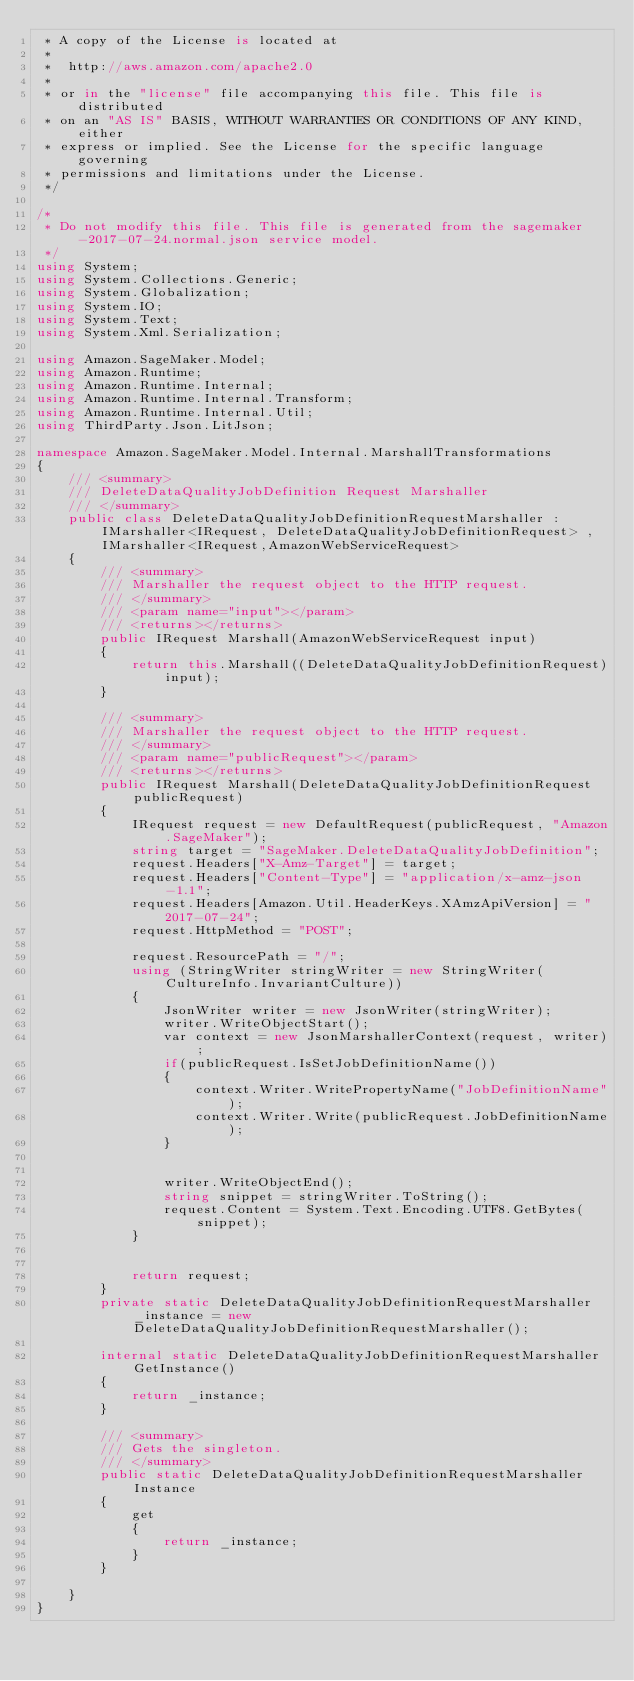Convert code to text. <code><loc_0><loc_0><loc_500><loc_500><_C#_> * A copy of the License is located at
 * 
 *  http://aws.amazon.com/apache2.0
 * 
 * or in the "license" file accompanying this file. This file is distributed
 * on an "AS IS" BASIS, WITHOUT WARRANTIES OR CONDITIONS OF ANY KIND, either
 * express or implied. See the License for the specific language governing
 * permissions and limitations under the License.
 */

/*
 * Do not modify this file. This file is generated from the sagemaker-2017-07-24.normal.json service model.
 */
using System;
using System.Collections.Generic;
using System.Globalization;
using System.IO;
using System.Text;
using System.Xml.Serialization;

using Amazon.SageMaker.Model;
using Amazon.Runtime;
using Amazon.Runtime.Internal;
using Amazon.Runtime.Internal.Transform;
using Amazon.Runtime.Internal.Util;
using ThirdParty.Json.LitJson;

namespace Amazon.SageMaker.Model.Internal.MarshallTransformations
{
    /// <summary>
    /// DeleteDataQualityJobDefinition Request Marshaller
    /// </summary>       
    public class DeleteDataQualityJobDefinitionRequestMarshaller : IMarshaller<IRequest, DeleteDataQualityJobDefinitionRequest> , IMarshaller<IRequest,AmazonWebServiceRequest>
    {
        /// <summary>
        /// Marshaller the request object to the HTTP request.
        /// </summary>  
        /// <param name="input"></param>
        /// <returns></returns>
        public IRequest Marshall(AmazonWebServiceRequest input)
        {
            return this.Marshall((DeleteDataQualityJobDefinitionRequest)input);
        }

        /// <summary>
        /// Marshaller the request object to the HTTP request.
        /// </summary>  
        /// <param name="publicRequest"></param>
        /// <returns></returns>
        public IRequest Marshall(DeleteDataQualityJobDefinitionRequest publicRequest)
        {
            IRequest request = new DefaultRequest(publicRequest, "Amazon.SageMaker");
            string target = "SageMaker.DeleteDataQualityJobDefinition";
            request.Headers["X-Amz-Target"] = target;
            request.Headers["Content-Type"] = "application/x-amz-json-1.1";
            request.Headers[Amazon.Util.HeaderKeys.XAmzApiVersion] = "2017-07-24";            
            request.HttpMethod = "POST";

            request.ResourcePath = "/";
            using (StringWriter stringWriter = new StringWriter(CultureInfo.InvariantCulture))
            {
                JsonWriter writer = new JsonWriter(stringWriter);
                writer.WriteObjectStart();
                var context = new JsonMarshallerContext(request, writer);
                if(publicRequest.IsSetJobDefinitionName())
                {
                    context.Writer.WritePropertyName("JobDefinitionName");
                    context.Writer.Write(publicRequest.JobDefinitionName);
                }

        
                writer.WriteObjectEnd();
                string snippet = stringWriter.ToString();
                request.Content = System.Text.Encoding.UTF8.GetBytes(snippet);
            }


            return request;
        }
        private static DeleteDataQualityJobDefinitionRequestMarshaller _instance = new DeleteDataQualityJobDefinitionRequestMarshaller();        

        internal static DeleteDataQualityJobDefinitionRequestMarshaller GetInstance()
        {
            return _instance;
        }

        /// <summary>
        /// Gets the singleton.
        /// </summary>  
        public static DeleteDataQualityJobDefinitionRequestMarshaller Instance
        {
            get
            {
                return _instance;
            }
        }

    }
}</code> 